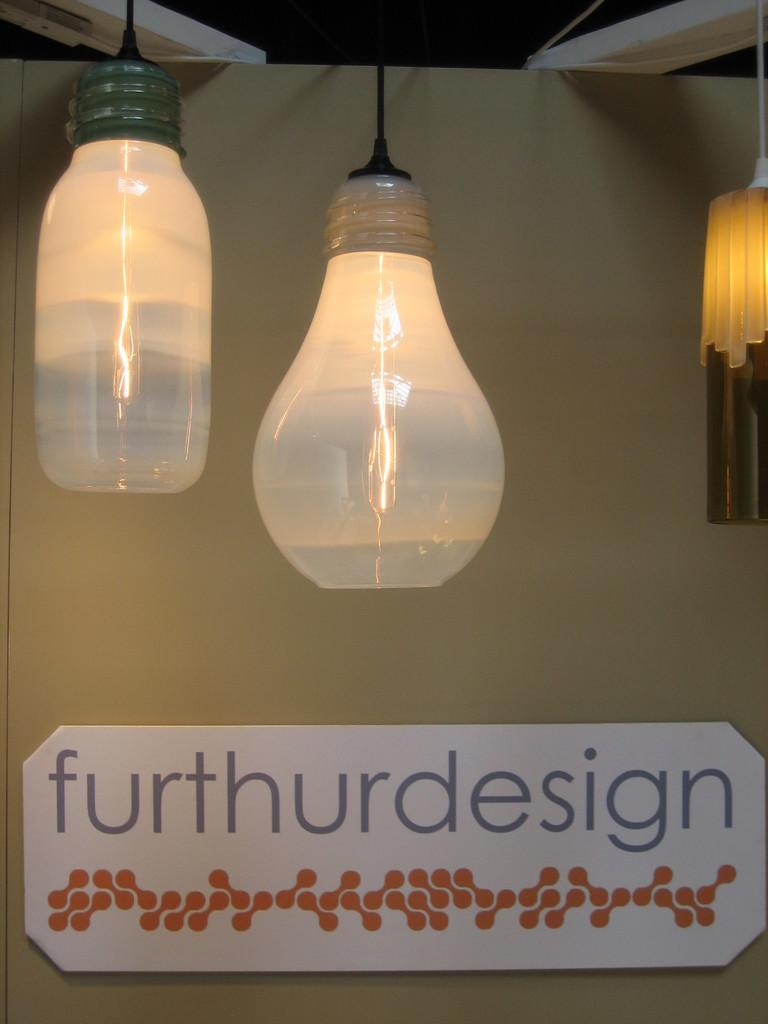<image>
Provide a brief description of the given image. a sign underneath a light bulb that says 'furthurdesign' 